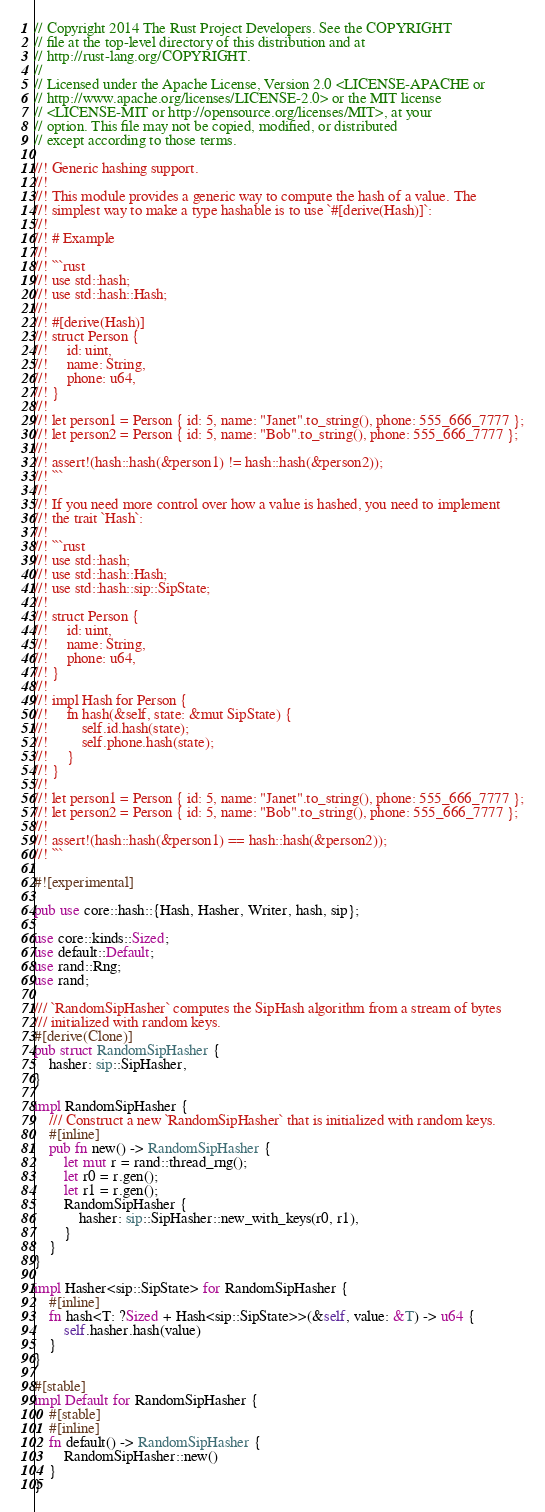Convert code to text. <code><loc_0><loc_0><loc_500><loc_500><_Rust_>// Copyright 2014 The Rust Project Developers. See the COPYRIGHT
// file at the top-level directory of this distribution and at
// http://rust-lang.org/COPYRIGHT.
//
// Licensed under the Apache License, Version 2.0 <LICENSE-APACHE or
// http://www.apache.org/licenses/LICENSE-2.0> or the MIT license
// <LICENSE-MIT or http://opensource.org/licenses/MIT>, at your
// option. This file may not be copied, modified, or distributed
// except according to those terms.

//! Generic hashing support.
//!
//! This module provides a generic way to compute the hash of a value. The
//! simplest way to make a type hashable is to use `#[derive(Hash)]`:
//!
//! # Example
//!
//! ```rust
//! use std::hash;
//! use std::hash::Hash;
//!
//! #[derive(Hash)]
//! struct Person {
//!     id: uint,
//!     name: String,
//!     phone: u64,
//! }
//!
//! let person1 = Person { id: 5, name: "Janet".to_string(), phone: 555_666_7777 };
//! let person2 = Person { id: 5, name: "Bob".to_string(), phone: 555_666_7777 };
//!
//! assert!(hash::hash(&person1) != hash::hash(&person2));
//! ```
//!
//! If you need more control over how a value is hashed, you need to implement
//! the trait `Hash`:
//!
//! ```rust
//! use std::hash;
//! use std::hash::Hash;
//! use std::hash::sip::SipState;
//!
//! struct Person {
//!     id: uint,
//!     name: String,
//!     phone: u64,
//! }
//!
//! impl Hash for Person {
//!     fn hash(&self, state: &mut SipState) {
//!         self.id.hash(state);
//!         self.phone.hash(state);
//!     }
//! }
//!
//! let person1 = Person { id: 5, name: "Janet".to_string(), phone: 555_666_7777 };
//! let person2 = Person { id: 5, name: "Bob".to_string(), phone: 555_666_7777 };
//!
//! assert!(hash::hash(&person1) == hash::hash(&person2));
//! ```

#![experimental]

pub use core::hash::{Hash, Hasher, Writer, hash, sip};

use core::kinds::Sized;
use default::Default;
use rand::Rng;
use rand;

/// `RandomSipHasher` computes the SipHash algorithm from a stream of bytes
/// initialized with random keys.
#[derive(Clone)]
pub struct RandomSipHasher {
    hasher: sip::SipHasher,
}

impl RandomSipHasher {
    /// Construct a new `RandomSipHasher` that is initialized with random keys.
    #[inline]
    pub fn new() -> RandomSipHasher {
        let mut r = rand::thread_rng();
        let r0 = r.gen();
        let r1 = r.gen();
        RandomSipHasher {
            hasher: sip::SipHasher::new_with_keys(r0, r1),
        }
    }
}

impl Hasher<sip::SipState> for RandomSipHasher {
    #[inline]
    fn hash<T: ?Sized + Hash<sip::SipState>>(&self, value: &T) -> u64 {
        self.hasher.hash(value)
    }
}

#[stable]
impl Default for RandomSipHasher {
    #[stable]
    #[inline]
    fn default() -> RandomSipHasher {
        RandomSipHasher::new()
    }
}
</code> 